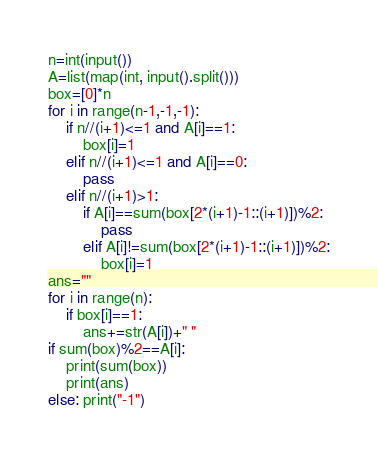<code> <loc_0><loc_0><loc_500><loc_500><_Python_>n=int(input())
A=list(map(int, input().split()))
box=[0]*n
for i in range(n-1,-1,-1):
    if n//(i+1)<=1 and A[i]==1:
        box[i]=1
    elif n//(i+1)<=1 and A[i]==0:
        pass
    elif n//(i+1)>1:
        if A[i]==sum(box[2*(i+1)-1::(i+1)])%2:
            pass
        elif A[i]!=sum(box[2*(i+1)-1::(i+1)])%2:
            box[i]=1
ans=""
for i in range(n):
    if box[i]==1:
        ans+=str(A[i])+" "
if sum(box)%2==A[i]:
    print(sum(box))
    print(ans)
else: print("-1")</code> 